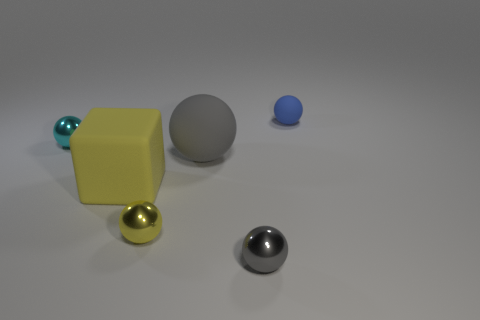The rubber sphere in front of the blue rubber ball is what color?
Your response must be concise. Gray. There is a ball that is behind the small cyan ball; is it the same size as the gray thing that is in front of the yellow shiny thing?
Offer a very short reply. Yes. Is there a red rubber object that has the same size as the cyan sphere?
Make the answer very short. No. What number of large yellow rubber blocks are behind the big matte thing that is right of the yellow sphere?
Provide a short and direct response. 0. What is the material of the tiny cyan ball?
Offer a very short reply. Metal. What number of small shiny objects are behind the tiny blue ball?
Ensure brevity in your answer.  0. Is the small rubber object the same color as the big sphere?
Your answer should be very brief. No. What number of tiny balls are the same color as the large cube?
Provide a succinct answer. 1. Is the number of tiny blue rubber balls greater than the number of big purple metallic blocks?
Give a very brief answer. Yes. There is a ball that is both behind the gray matte sphere and left of the tiny gray thing; what is its size?
Your answer should be compact. Small. 